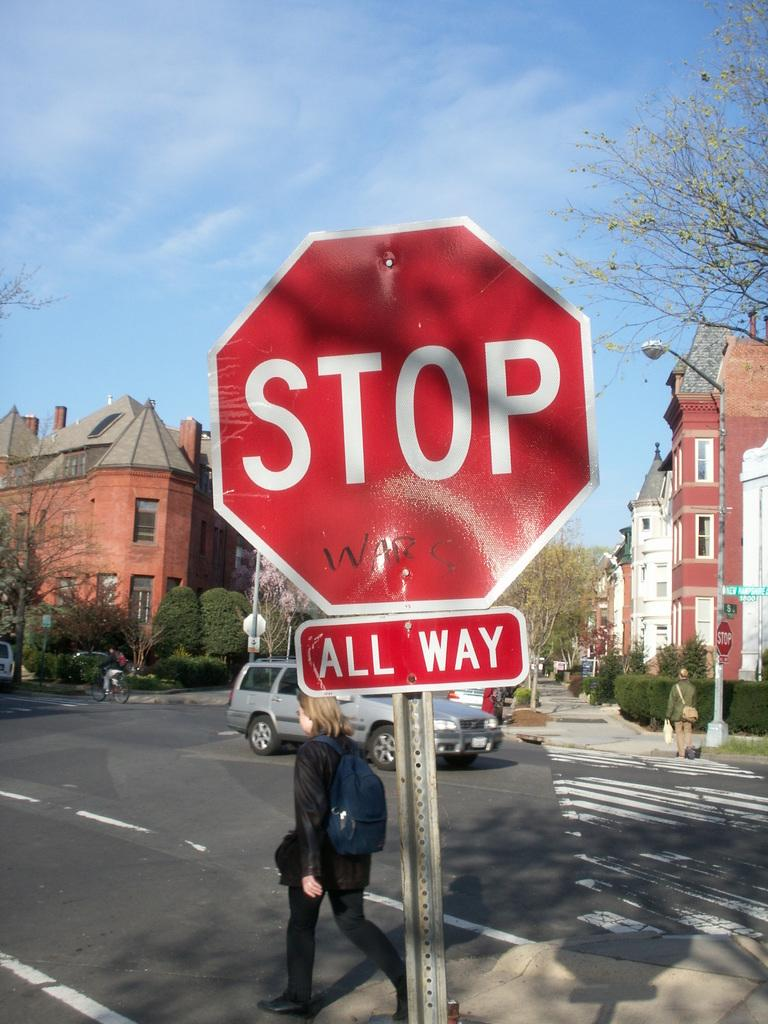Provide a one-sentence caption for the provided image. A, Stop All Way, sign at an intersection with people and vehicles behind it. 